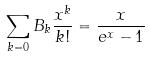<formula> <loc_0><loc_0><loc_500><loc_500>\sum _ { k = 0 } B _ { k } \frac { x ^ { k } } { k ! } = \frac { x } { e ^ { x } - 1 }</formula> 